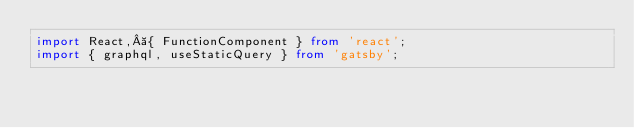<code> <loc_0><loc_0><loc_500><loc_500><_TypeScript_>import React, { FunctionComponent } from 'react';
import { graphql, useStaticQuery } from 'gatsby';</code> 